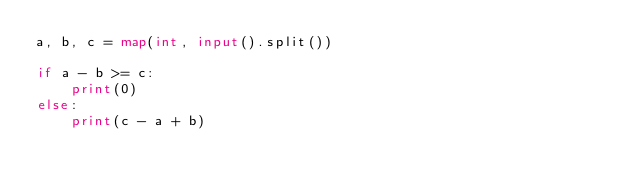Convert code to text. <code><loc_0><loc_0><loc_500><loc_500><_Python_>a, b, c = map(int, input().split())

if a - b >= c:
    print(0)
else:
    print(c - a + b)
</code> 